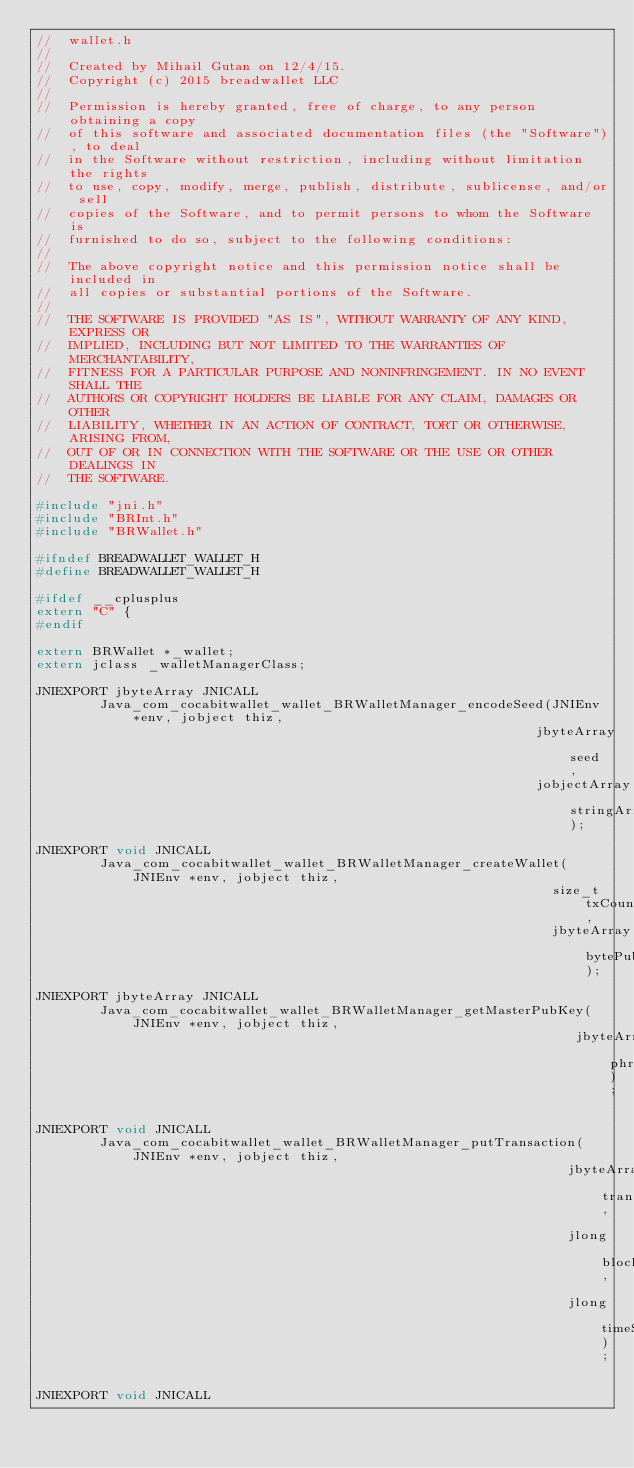Convert code to text. <code><loc_0><loc_0><loc_500><loc_500><_C_>//  wallet.h
//
//  Created by Mihail Gutan on 12/4/15.
//  Copyright (c) 2015 breadwallet LLC
//
//  Permission is hereby granted, free of charge, to any person obtaining a copy
//  of this software and associated documentation files (the "Software"), to deal
//  in the Software without restriction, including without limitation the rights
//  to use, copy, modify, merge, publish, distribute, sublicense, and/or sell
//  copies of the Software, and to permit persons to whom the Software is
//  furnished to do so, subject to the following conditions:
//
//  The above copyright notice and this permission notice shall be included in
//  all copies or substantial portions of the Software.
//
//  THE SOFTWARE IS PROVIDED "AS IS", WITHOUT WARRANTY OF ANY KIND, EXPRESS OR
//  IMPLIED, INCLUDING BUT NOT LIMITED TO THE WARRANTIES OF MERCHANTABILITY,
//  FITNESS FOR A PARTICULAR PURPOSE AND NONINFRINGEMENT. IN NO EVENT SHALL THE
//  AUTHORS OR COPYRIGHT HOLDERS BE LIABLE FOR ANY CLAIM, DAMAGES OR OTHER
//  LIABILITY, WHETHER IN AN ACTION OF CONTRACT, TORT OR OTHERWISE, ARISING FROM,
//  OUT OF OR IN CONNECTION WITH THE SOFTWARE OR THE USE OR OTHER DEALINGS IN
//  THE SOFTWARE.

#include "jni.h"
#include "BRInt.h"
#include "BRWallet.h"

#ifndef BREADWALLET_WALLET_H
#define BREADWALLET_WALLET_H

#ifdef __cplusplus
extern "C" {
#endif

extern BRWallet *_wallet;
extern jclass _walletManagerClass;

JNIEXPORT jbyteArray JNICALL
        Java_com_cocabitwallet_wallet_BRWalletManager_encodeSeed(JNIEnv *env, jobject thiz,
                                                               jbyteArray seed,
                                                               jobjectArray stringArray);

JNIEXPORT void JNICALL
        Java_com_cocabitwallet_wallet_BRWalletManager_createWallet(JNIEnv *env, jobject thiz,
                                                                 size_t txCount,
                                                                 jbyteArray bytePubKey);

JNIEXPORT jbyteArray JNICALL
        Java_com_cocabitwallet_wallet_BRWalletManager_getMasterPubKey(JNIEnv *env, jobject thiz,
                                                                    jbyteArray phrase);

JNIEXPORT void JNICALL
        Java_com_cocabitwallet_wallet_BRWalletManager_putTransaction(JNIEnv *env, jobject thiz,
                                                                   jbyteArray transaction,
                                                                   jlong blockHeight,
                                                                   jlong timeStamp);

JNIEXPORT void JNICALL</code> 